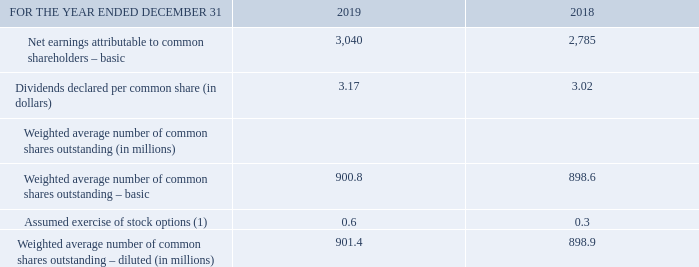Note 9 Earnings per share
The following table shows the components used in the calculation of basic and diluted earnings per common share for earnings attributable to common shareholders.
(1) The calculation of the assumed exercise of stock options includes the effect of the average unrecognized future compensation cost of dilutive options. It excludes options for which the exercise price is higher than the average market value of a BCE common share. The number of excluded options was 61,170 in 2019 and 12,252,594 in 2018.
What does the calculation of the assumed exercise of stock options include? The effect of the average unrecognized future compensation cost of dilutive options. What does the calculation of the assumed exercise of stock options exclude? Options for which the exercise price is higher than the average market value of a bce common share. What is the Net earnings attributable to common shareholders – basic for 2019? 3,040. What is the change in the number of excluded options in 2019? 61,170-12,252,594
Answer: -12191424. What is the total net earnings attributable to common shareholders - basic in 2018 and 2019? 3,040+2,785
Answer: 5825. What is the percentage change in the weighted average number of common shares outstanding - diluted?
Answer scale should be: percent. (901.4-898.9)/898.9
Answer: 0.28. 